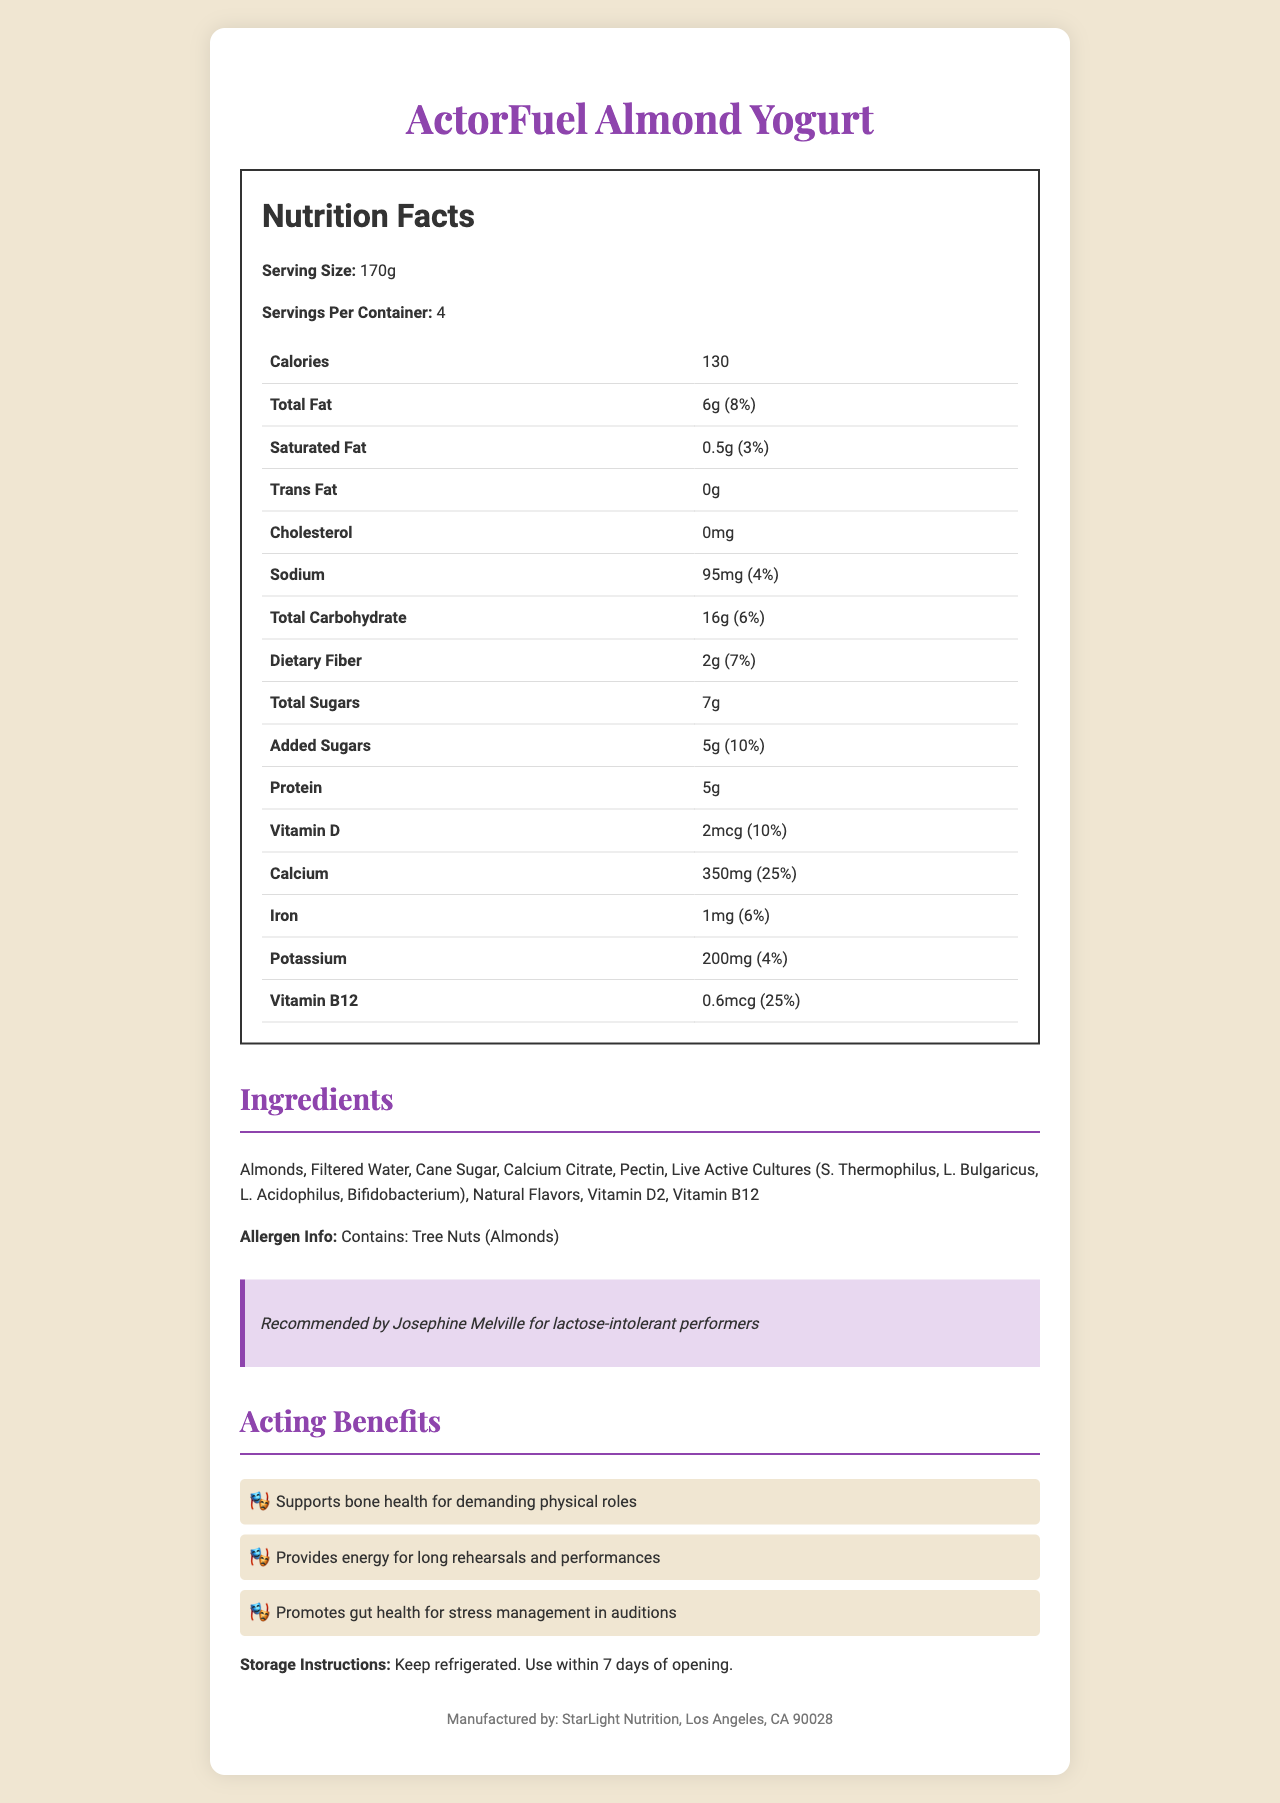what is the serving size of ActorFuel Almond Yogurt? The serving size is specifically mentioned as 170g in the Nutrition Facts section.
Answer: 170g how many servings are there in a container? The number of servings per container is stated as 4 in the Nutrition Facts section.
Answer: 4 how many calories are in one serving? The document lists 130 calories in the Nutrition Facts section for one serving of the yogurt.
Answer: 130 what is the amount of total fat in one serving? The amount of total fat per serving is given as 6g.
Answer: 6g what is the daily value percentage for iron? The daily value percentage for iron is listed as 6% in the Nutrition Facts section.
Answer: 6% what kind of fat is not present in the yogurt? A. Saturated Fat B. Trans Fat C. Total Fat The Nutrition Facts indicate that the yogurt has 0g of Trans Fat.
Answer: B which vitamin has the highest daily value percentage in the yogurt? A. Vitamin D B. Calcium C. Vitamin B12 Vitamin B12 has the highest daily value percentage at 25%, along with calcium, according to the Nutrition Facts section.
Answer: C is this product recommended by a celebrity? The document mentions a celebrity endorsement: "Recommended by Josephine Melville for lactose-intolerant performers."
Answer: Yes describe the type of ingredients used in ActorFuel Almond Yogurt The ingredients section lists various natural ingredients and added vitamins.
Answer: Mostly natural ingredients like almonds, filtered water, and cane sugar are used along with added vitamins and live active cultures. what are the possible allergen concerns with this product? The allergen info specifically states that the product contains tree nuts (almonds).
Answer: Tree Nuts (Almonds) what kind of benefits does the yogurt provide for actors? The acting benefits section lists these three main benefits.
Answer: It supports bone health, provides energy for long rehearsals and performances, and promotes gut health for stress management in auditions. how should the yogurt be stored after opening? The storage instructions state that the yogurt should be kept refrigerated and used within 7 days after opening.
Answer: Keep refrigerated. Use within 7 days of opening. what is the amount of added sugars? The Nutrition Facts indicate that there are 5g of added sugars.
Answer: 5g where is the yogurt manufactured? The manufacturer information at the bottom of the document shows that it is manufactured by StarLight Nutrition in Los Angeles, CA 90028.
Answer: Los Angeles, CA 90028 can the expiration date of the yogurt be identified from the document? The document does not provide information about the expiration date of the yogurt.
Answer: Not enough information 